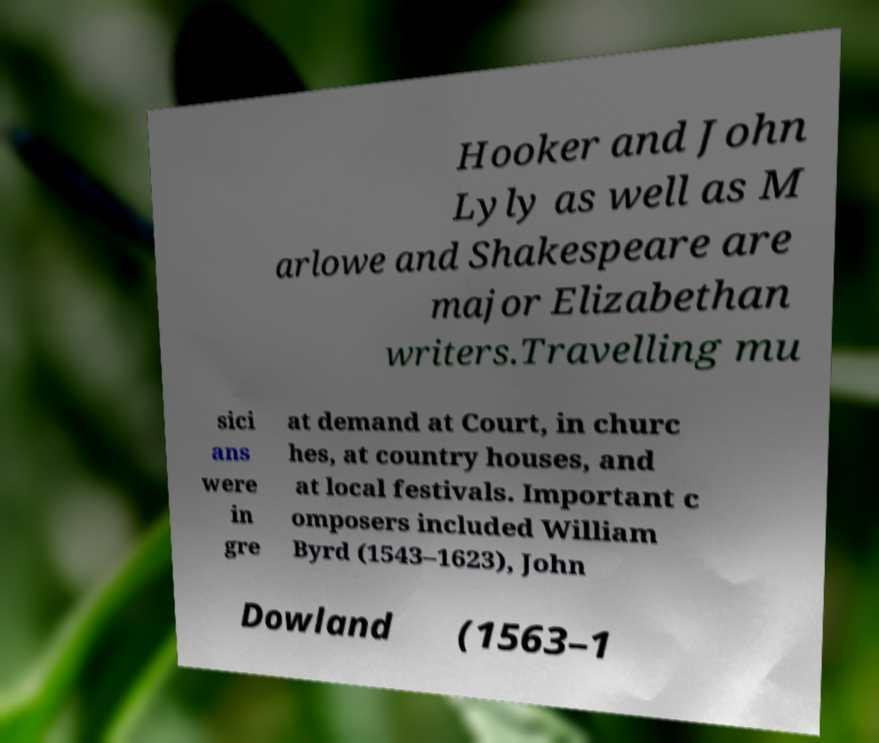Can you read and provide the text displayed in the image?This photo seems to have some interesting text. Can you extract and type it out for me? Hooker and John Lyly as well as M arlowe and Shakespeare are major Elizabethan writers.Travelling mu sici ans were in gre at demand at Court, in churc hes, at country houses, and at local festivals. Important c omposers included William Byrd (1543–1623), John Dowland (1563–1 